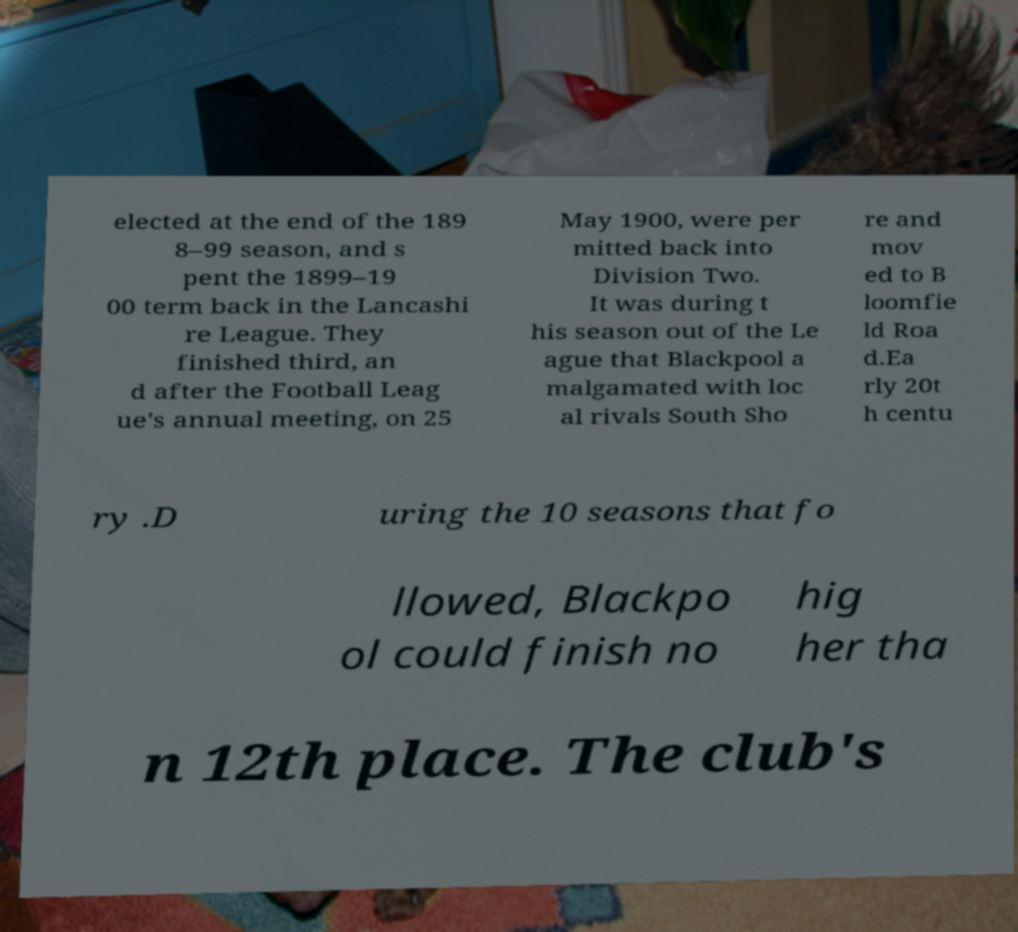Can you accurately transcribe the text from the provided image for me? elected at the end of the 189 8–99 season, and s pent the 1899–19 00 term back in the Lancashi re League. They finished third, an d after the Football Leag ue's annual meeting, on 25 May 1900, were per mitted back into Division Two. It was during t his season out of the Le ague that Blackpool a malgamated with loc al rivals South Sho re and mov ed to B loomfie ld Roa d.Ea rly 20t h centu ry .D uring the 10 seasons that fo llowed, Blackpo ol could finish no hig her tha n 12th place. The club's 